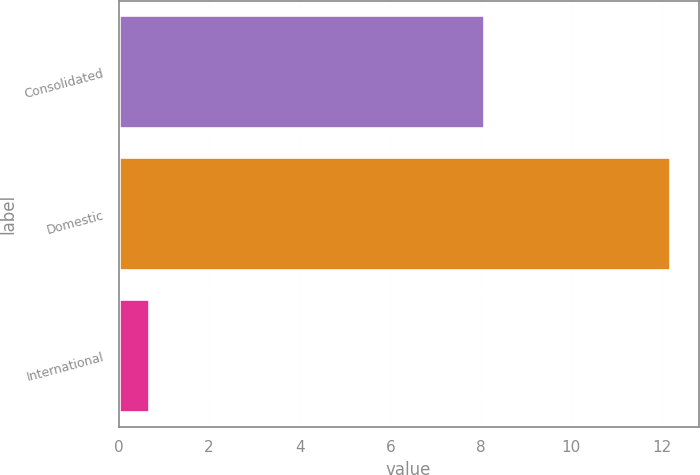Convert chart. <chart><loc_0><loc_0><loc_500><loc_500><bar_chart><fcel>Consolidated<fcel>Domestic<fcel>International<nl><fcel>8.1<fcel>12.2<fcel>0.7<nl></chart> 